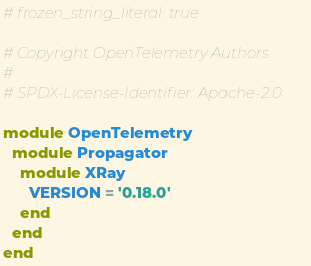Convert code to text. <code><loc_0><loc_0><loc_500><loc_500><_Ruby_># frozen_string_literal: true

# Copyright OpenTelemetry Authors
#
# SPDX-License-Identifier: Apache-2.0

module OpenTelemetry
  module Propagator
    module XRay
      VERSION = '0.18.0'
    end
  end
end
</code> 